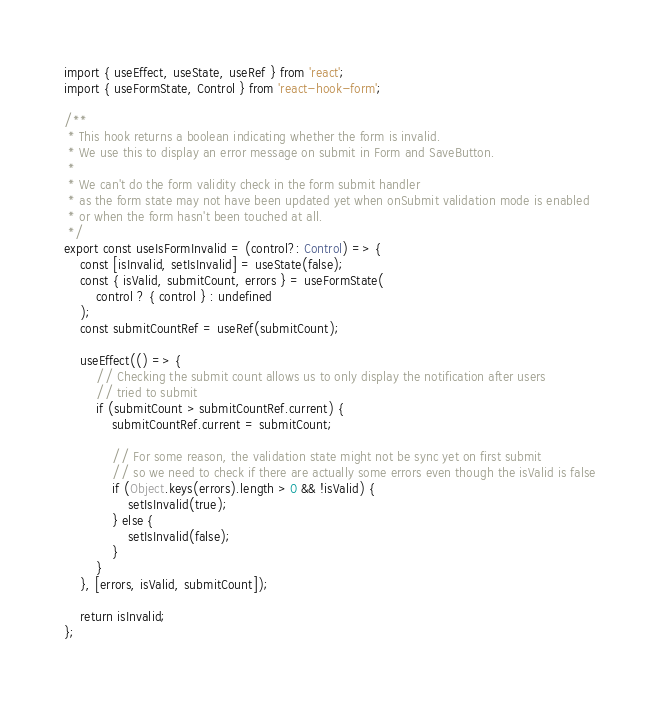<code> <loc_0><loc_0><loc_500><loc_500><_TypeScript_>import { useEffect, useState, useRef } from 'react';
import { useFormState, Control } from 'react-hook-form';

/**
 * This hook returns a boolean indicating whether the form is invalid.
 * We use this to display an error message on submit in Form and SaveButton.
 *
 * We can't do the form validity check in the form submit handler
 * as the form state may not have been updated yet when onSubmit validation mode is enabled
 * or when the form hasn't been touched at all.
 */
export const useIsFormInvalid = (control?: Control) => {
    const [isInvalid, setIsInvalid] = useState(false);
    const { isValid, submitCount, errors } = useFormState(
        control ? { control } : undefined
    );
    const submitCountRef = useRef(submitCount);

    useEffect(() => {
        // Checking the submit count allows us to only display the notification after users
        // tried to submit
        if (submitCount > submitCountRef.current) {
            submitCountRef.current = submitCount;

            // For some reason, the validation state might not be sync yet on first submit
            // so we need to check if there are actually some errors even though the isValid is false
            if (Object.keys(errors).length > 0 && !isValid) {
                setIsInvalid(true);
            } else {
                setIsInvalid(false);
            }
        }
    }, [errors, isValid, submitCount]);

    return isInvalid;
};
</code> 